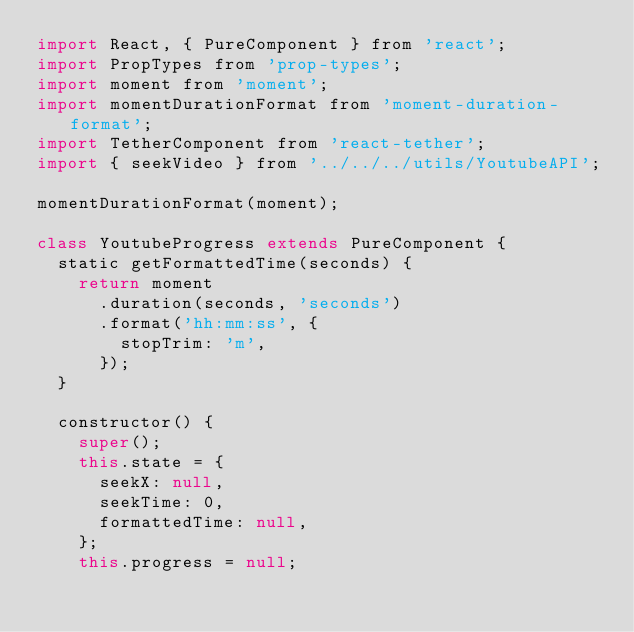<code> <loc_0><loc_0><loc_500><loc_500><_JavaScript_>import React, { PureComponent } from 'react';
import PropTypes from 'prop-types';
import moment from 'moment';
import momentDurationFormat from 'moment-duration-format';
import TetherComponent from 'react-tether';
import { seekVideo } from '../../../utils/YoutubeAPI';

momentDurationFormat(moment);

class YoutubeProgress extends PureComponent {
  static getFormattedTime(seconds) {
    return moment
      .duration(seconds, 'seconds')
      .format('hh:mm:ss', {
        stopTrim: 'm',
      });
  }

  constructor() {
    super();
    this.state = {
      seekX: null,
      seekTime: 0,
      formattedTime: null,
    };
    this.progress = null;
</code> 